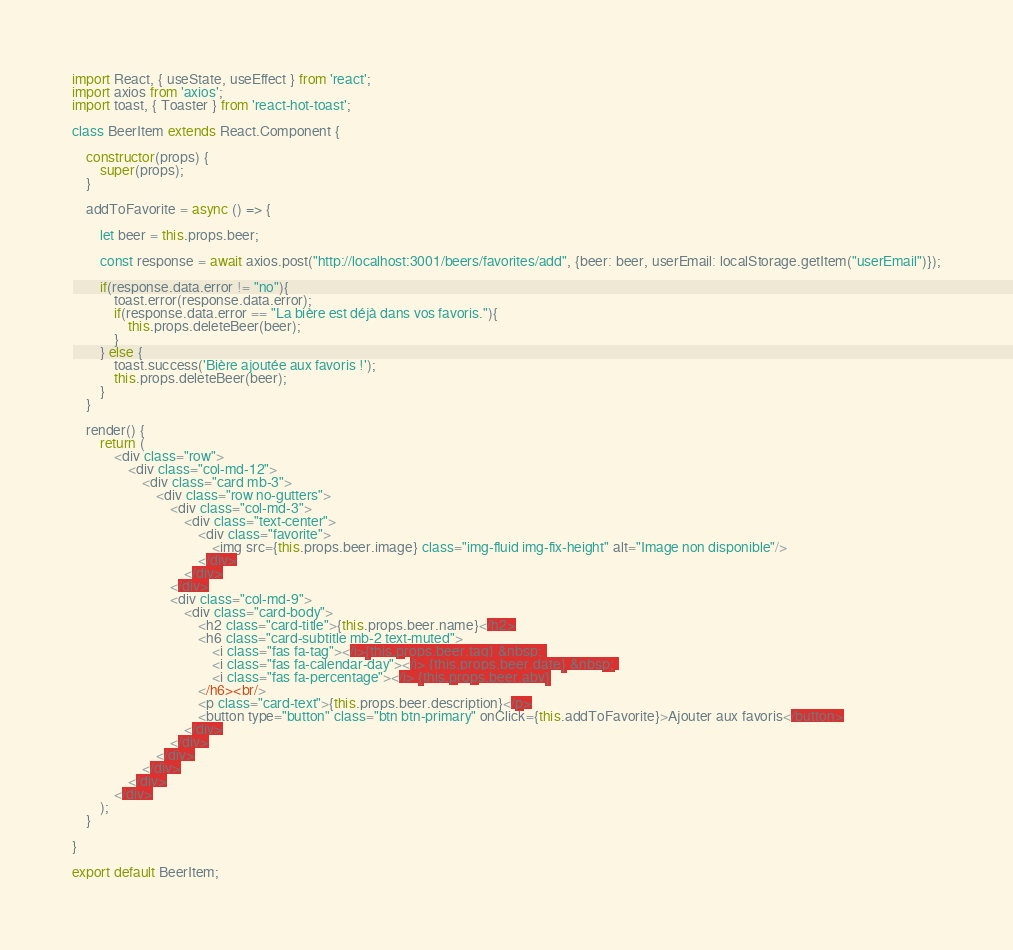Convert code to text. <code><loc_0><loc_0><loc_500><loc_500><_JavaScript_>import React, { useState, useEffect } from 'react';
import axios from 'axios';
import toast, { Toaster } from 'react-hot-toast';

class BeerItem extends React.Component {

    constructor(props) {
        super(props);
    }

    addToFavorite = async () => {

        let beer = this.props.beer;

        const response = await axios.post("http://localhost:3001/beers/favorites/add", {beer: beer, userEmail: localStorage.getItem("userEmail")});

        if(response.data.error != "no"){
            toast.error(response.data.error);
            if(response.data.error == "La bière est déjà dans vos favoris."){
                this.props.deleteBeer(beer);
            }
        } else {
            toast.success('Bière ajoutée aux favoris !');
            this.props.deleteBeer(beer);
        }
    }

    render() {
        return (
            <div class="row">
                <div class="col-md-12">
                    <div class="card mb-3">
                        <div class="row no-gutters">
                            <div class="col-md-3">
                                <div class="text-center">
                                    <div class="favorite">
                                        <img src={this.props.beer.image} class="img-fluid img-fix-height" alt="Image non disponible"/>
                                    </div>
                                </div>
                            </div>
                            <div class="col-md-9">
                                <div class="card-body">
                                    <h2 class="card-title">{this.props.beer.name}</h2>
                                    <h6 class="card-subtitle mb-2 text-muted">
                                        <i class="fas fa-tag"></i>{this.props.beer.tag} &nbsp; 
                                        <i class="fas fa-calendar-day"></i> {this.props.beer.date} &nbsp; 
                                        <i class="fas fa-percentage"></i> {this.props.beer.abv}
                                    </h6><br/>
                                    <p class="card-text">{this.props.beer.description}</p>
                                    <button type="button" class="btn btn-primary" onClick={this.addToFavorite}>Ajouter aux favoris</button>
                                </div>
                            </div>
                        </div>
                    </div>
                </div>
            </div>
        );
    }

}

export default BeerItem;</code> 